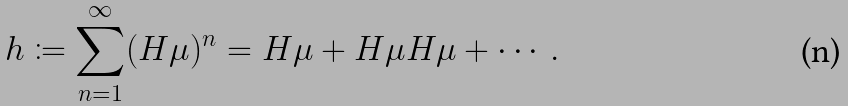<formula> <loc_0><loc_0><loc_500><loc_500>h \coloneqq \sum _ { n = 1 } ^ { \infty } ( H \mu ) ^ { n } = H \mu + H \mu H \mu + \cdots .</formula> 